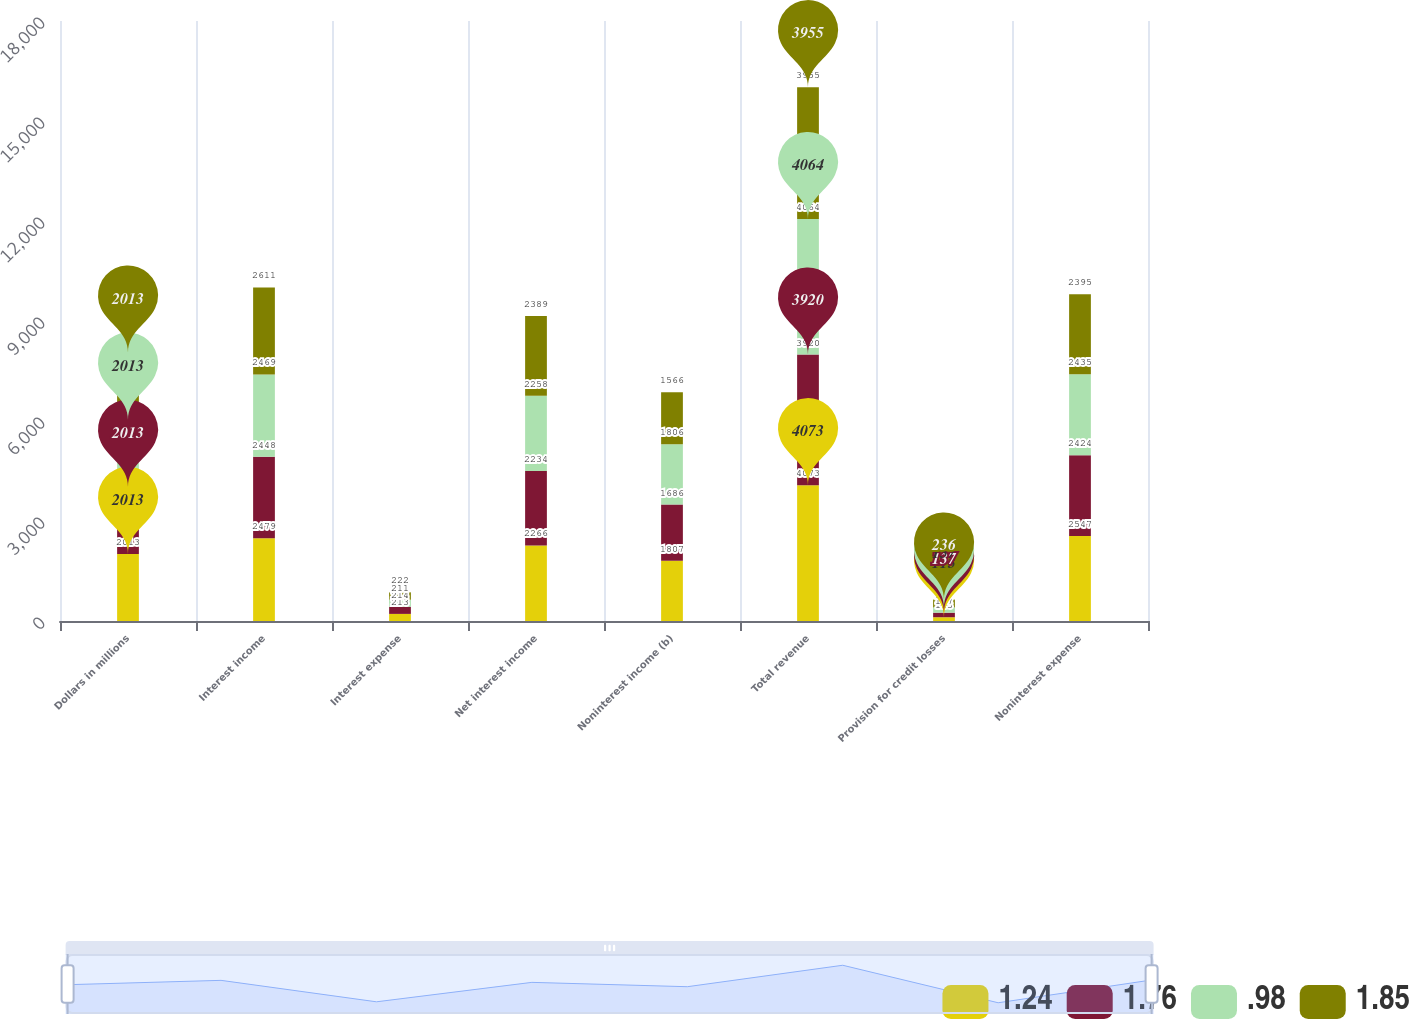Convert chart. <chart><loc_0><loc_0><loc_500><loc_500><stacked_bar_chart><ecel><fcel>Dollars in millions<fcel>Interest income<fcel>Interest expense<fcel>Net interest income<fcel>Noninterest income (b)<fcel>Total revenue<fcel>Provision for credit losses<fcel>Noninterest expense<nl><fcel>1.24<fcel>2013<fcel>2479<fcel>213<fcel>2266<fcel>1807<fcel>4073<fcel>113<fcel>2547<nl><fcel>1.76<fcel>2013<fcel>2448<fcel>214<fcel>2234<fcel>1686<fcel>3920<fcel>137<fcel>2424<nl><fcel>0.98<fcel>2013<fcel>2469<fcel>211<fcel>2258<fcel>1806<fcel>4064<fcel>157<fcel>2435<nl><fcel>1.85<fcel>2013<fcel>2611<fcel>222<fcel>2389<fcel>1566<fcel>3955<fcel>236<fcel>2395<nl></chart> 